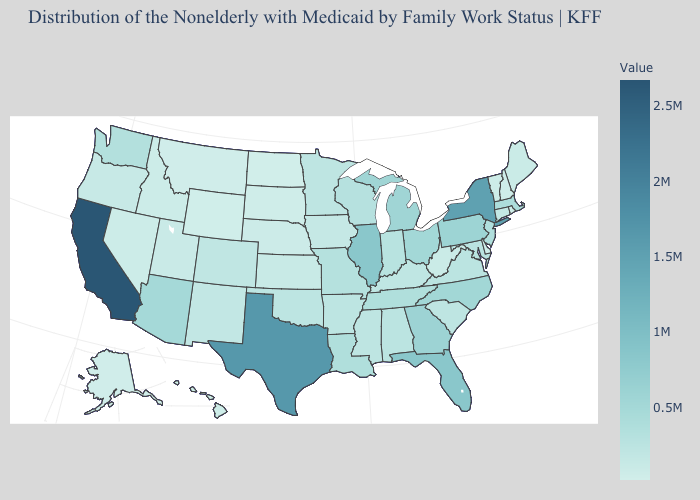Among the states that border Wisconsin , does Iowa have the lowest value?
Concise answer only. Yes. Does North Dakota have the lowest value in the USA?
Be succinct. Yes. Among the states that border Nevada , which have the highest value?
Be succinct. California. 